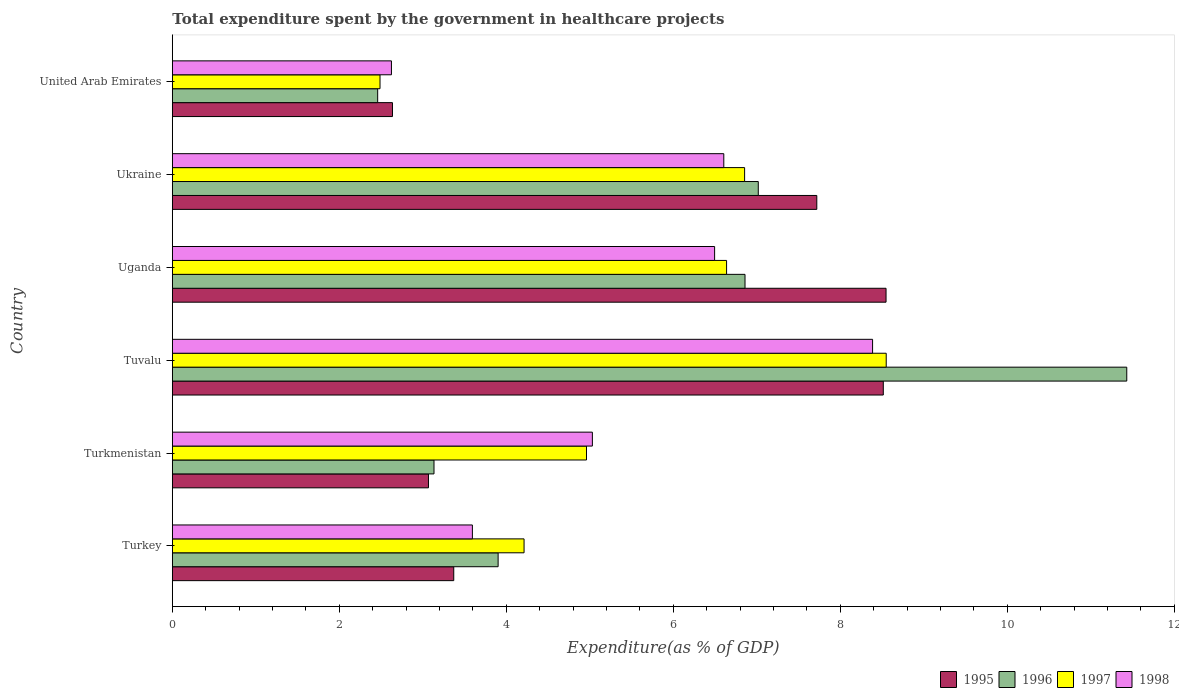Are the number of bars per tick equal to the number of legend labels?
Make the answer very short. Yes. What is the label of the 1st group of bars from the top?
Make the answer very short. United Arab Emirates. What is the total expenditure spent by the government in healthcare projects in 1997 in Uganda?
Provide a short and direct response. 6.64. Across all countries, what is the maximum total expenditure spent by the government in healthcare projects in 1996?
Provide a succinct answer. 11.43. Across all countries, what is the minimum total expenditure spent by the government in healthcare projects in 1995?
Offer a very short reply. 2.64. In which country was the total expenditure spent by the government in healthcare projects in 1996 maximum?
Your response must be concise. Tuvalu. In which country was the total expenditure spent by the government in healthcare projects in 1998 minimum?
Your response must be concise. United Arab Emirates. What is the total total expenditure spent by the government in healthcare projects in 1997 in the graph?
Keep it short and to the point. 33.7. What is the difference between the total expenditure spent by the government in healthcare projects in 1996 in Turkey and that in Uganda?
Provide a succinct answer. -2.96. What is the difference between the total expenditure spent by the government in healthcare projects in 1996 in Turkey and the total expenditure spent by the government in healthcare projects in 1998 in Uganda?
Offer a terse response. -2.59. What is the average total expenditure spent by the government in healthcare projects in 1997 per country?
Give a very brief answer. 5.62. What is the difference between the total expenditure spent by the government in healthcare projects in 1997 and total expenditure spent by the government in healthcare projects in 1998 in Tuvalu?
Offer a very short reply. 0.16. In how many countries, is the total expenditure spent by the government in healthcare projects in 1995 greater than 2.4 %?
Offer a very short reply. 6. What is the ratio of the total expenditure spent by the government in healthcare projects in 1997 in Tuvalu to that in Ukraine?
Your answer should be very brief. 1.25. Is the total expenditure spent by the government in healthcare projects in 1997 in Turkey less than that in Turkmenistan?
Give a very brief answer. Yes. Is the difference between the total expenditure spent by the government in healthcare projects in 1997 in Turkey and Uganda greater than the difference between the total expenditure spent by the government in healthcare projects in 1998 in Turkey and Uganda?
Keep it short and to the point. Yes. What is the difference between the highest and the second highest total expenditure spent by the government in healthcare projects in 1995?
Provide a succinct answer. 0.03. What is the difference between the highest and the lowest total expenditure spent by the government in healthcare projects in 1998?
Give a very brief answer. 5.76. In how many countries, is the total expenditure spent by the government in healthcare projects in 1995 greater than the average total expenditure spent by the government in healthcare projects in 1995 taken over all countries?
Provide a succinct answer. 3. Is the sum of the total expenditure spent by the government in healthcare projects in 1998 in Turkmenistan and Ukraine greater than the maximum total expenditure spent by the government in healthcare projects in 1996 across all countries?
Keep it short and to the point. Yes. Is it the case that in every country, the sum of the total expenditure spent by the government in healthcare projects in 1998 and total expenditure spent by the government in healthcare projects in 1995 is greater than the sum of total expenditure spent by the government in healthcare projects in 1997 and total expenditure spent by the government in healthcare projects in 1996?
Your answer should be very brief. No. Is it the case that in every country, the sum of the total expenditure spent by the government in healthcare projects in 1995 and total expenditure spent by the government in healthcare projects in 1997 is greater than the total expenditure spent by the government in healthcare projects in 1996?
Your answer should be very brief. Yes. Are all the bars in the graph horizontal?
Provide a short and direct response. Yes. How many countries are there in the graph?
Your answer should be very brief. 6. Are the values on the major ticks of X-axis written in scientific E-notation?
Your response must be concise. No. Does the graph contain grids?
Your response must be concise. No. Where does the legend appear in the graph?
Your response must be concise. Bottom right. How many legend labels are there?
Offer a terse response. 4. How are the legend labels stacked?
Keep it short and to the point. Horizontal. What is the title of the graph?
Ensure brevity in your answer.  Total expenditure spent by the government in healthcare projects. Does "2008" appear as one of the legend labels in the graph?
Your answer should be very brief. No. What is the label or title of the X-axis?
Your answer should be very brief. Expenditure(as % of GDP). What is the label or title of the Y-axis?
Provide a succinct answer. Country. What is the Expenditure(as % of GDP) in 1995 in Turkey?
Offer a terse response. 3.37. What is the Expenditure(as % of GDP) of 1996 in Turkey?
Your answer should be very brief. 3.9. What is the Expenditure(as % of GDP) in 1997 in Turkey?
Your response must be concise. 4.21. What is the Expenditure(as % of GDP) in 1998 in Turkey?
Your answer should be very brief. 3.59. What is the Expenditure(as % of GDP) of 1995 in Turkmenistan?
Give a very brief answer. 3.07. What is the Expenditure(as % of GDP) of 1996 in Turkmenistan?
Your answer should be compact. 3.13. What is the Expenditure(as % of GDP) in 1997 in Turkmenistan?
Offer a terse response. 4.96. What is the Expenditure(as % of GDP) of 1998 in Turkmenistan?
Your response must be concise. 5.03. What is the Expenditure(as % of GDP) of 1995 in Tuvalu?
Provide a succinct answer. 8.51. What is the Expenditure(as % of GDP) in 1996 in Tuvalu?
Your response must be concise. 11.43. What is the Expenditure(as % of GDP) in 1997 in Tuvalu?
Offer a very short reply. 8.55. What is the Expenditure(as % of GDP) of 1998 in Tuvalu?
Provide a short and direct response. 8.39. What is the Expenditure(as % of GDP) in 1995 in Uganda?
Ensure brevity in your answer.  8.55. What is the Expenditure(as % of GDP) in 1996 in Uganda?
Make the answer very short. 6.86. What is the Expenditure(as % of GDP) of 1997 in Uganda?
Keep it short and to the point. 6.64. What is the Expenditure(as % of GDP) in 1998 in Uganda?
Your response must be concise. 6.49. What is the Expenditure(as % of GDP) in 1995 in Ukraine?
Offer a terse response. 7.72. What is the Expenditure(as % of GDP) of 1996 in Ukraine?
Your answer should be very brief. 7.02. What is the Expenditure(as % of GDP) of 1997 in Ukraine?
Provide a short and direct response. 6.85. What is the Expenditure(as % of GDP) in 1998 in Ukraine?
Make the answer very short. 6.6. What is the Expenditure(as % of GDP) in 1995 in United Arab Emirates?
Ensure brevity in your answer.  2.64. What is the Expenditure(as % of GDP) in 1996 in United Arab Emirates?
Make the answer very short. 2.46. What is the Expenditure(as % of GDP) of 1997 in United Arab Emirates?
Make the answer very short. 2.49. What is the Expenditure(as % of GDP) in 1998 in United Arab Emirates?
Offer a terse response. 2.62. Across all countries, what is the maximum Expenditure(as % of GDP) of 1995?
Provide a succinct answer. 8.55. Across all countries, what is the maximum Expenditure(as % of GDP) of 1996?
Offer a terse response. 11.43. Across all countries, what is the maximum Expenditure(as % of GDP) in 1997?
Make the answer very short. 8.55. Across all countries, what is the maximum Expenditure(as % of GDP) in 1998?
Provide a succinct answer. 8.39. Across all countries, what is the minimum Expenditure(as % of GDP) in 1995?
Provide a short and direct response. 2.64. Across all countries, what is the minimum Expenditure(as % of GDP) of 1996?
Your answer should be very brief. 2.46. Across all countries, what is the minimum Expenditure(as % of GDP) in 1997?
Give a very brief answer. 2.49. Across all countries, what is the minimum Expenditure(as % of GDP) in 1998?
Ensure brevity in your answer.  2.62. What is the total Expenditure(as % of GDP) of 1995 in the graph?
Provide a succinct answer. 33.85. What is the total Expenditure(as % of GDP) in 1996 in the graph?
Your response must be concise. 34.8. What is the total Expenditure(as % of GDP) in 1997 in the graph?
Make the answer very short. 33.7. What is the total Expenditure(as % of GDP) in 1998 in the graph?
Ensure brevity in your answer.  32.73. What is the difference between the Expenditure(as % of GDP) of 1995 in Turkey and that in Turkmenistan?
Your answer should be compact. 0.3. What is the difference between the Expenditure(as % of GDP) in 1996 in Turkey and that in Turkmenistan?
Offer a terse response. 0.77. What is the difference between the Expenditure(as % of GDP) in 1997 in Turkey and that in Turkmenistan?
Your answer should be very brief. -0.75. What is the difference between the Expenditure(as % of GDP) in 1998 in Turkey and that in Turkmenistan?
Give a very brief answer. -1.44. What is the difference between the Expenditure(as % of GDP) of 1995 in Turkey and that in Tuvalu?
Offer a terse response. -5.14. What is the difference between the Expenditure(as % of GDP) of 1996 in Turkey and that in Tuvalu?
Keep it short and to the point. -7.53. What is the difference between the Expenditure(as % of GDP) of 1997 in Turkey and that in Tuvalu?
Your response must be concise. -4.34. What is the difference between the Expenditure(as % of GDP) of 1998 in Turkey and that in Tuvalu?
Your answer should be compact. -4.79. What is the difference between the Expenditure(as % of GDP) of 1995 in Turkey and that in Uganda?
Provide a short and direct response. -5.18. What is the difference between the Expenditure(as % of GDP) of 1996 in Turkey and that in Uganda?
Offer a very short reply. -2.96. What is the difference between the Expenditure(as % of GDP) in 1997 in Turkey and that in Uganda?
Your response must be concise. -2.43. What is the difference between the Expenditure(as % of GDP) in 1998 in Turkey and that in Uganda?
Your response must be concise. -2.9. What is the difference between the Expenditure(as % of GDP) in 1995 in Turkey and that in Ukraine?
Your response must be concise. -4.35. What is the difference between the Expenditure(as % of GDP) of 1996 in Turkey and that in Ukraine?
Give a very brief answer. -3.12. What is the difference between the Expenditure(as % of GDP) of 1997 in Turkey and that in Ukraine?
Provide a succinct answer. -2.64. What is the difference between the Expenditure(as % of GDP) in 1998 in Turkey and that in Ukraine?
Offer a terse response. -3.01. What is the difference between the Expenditure(as % of GDP) in 1995 in Turkey and that in United Arab Emirates?
Ensure brevity in your answer.  0.73. What is the difference between the Expenditure(as % of GDP) in 1996 in Turkey and that in United Arab Emirates?
Provide a succinct answer. 1.44. What is the difference between the Expenditure(as % of GDP) in 1997 in Turkey and that in United Arab Emirates?
Offer a terse response. 1.73. What is the difference between the Expenditure(as % of GDP) in 1998 in Turkey and that in United Arab Emirates?
Your answer should be very brief. 0.97. What is the difference between the Expenditure(as % of GDP) of 1995 in Turkmenistan and that in Tuvalu?
Your response must be concise. -5.45. What is the difference between the Expenditure(as % of GDP) of 1996 in Turkmenistan and that in Tuvalu?
Provide a short and direct response. -8.3. What is the difference between the Expenditure(as % of GDP) in 1997 in Turkmenistan and that in Tuvalu?
Give a very brief answer. -3.59. What is the difference between the Expenditure(as % of GDP) of 1998 in Turkmenistan and that in Tuvalu?
Keep it short and to the point. -3.36. What is the difference between the Expenditure(as % of GDP) in 1995 in Turkmenistan and that in Uganda?
Your answer should be very brief. -5.48. What is the difference between the Expenditure(as % of GDP) of 1996 in Turkmenistan and that in Uganda?
Offer a terse response. -3.73. What is the difference between the Expenditure(as % of GDP) of 1997 in Turkmenistan and that in Uganda?
Keep it short and to the point. -1.68. What is the difference between the Expenditure(as % of GDP) of 1998 in Turkmenistan and that in Uganda?
Provide a short and direct response. -1.46. What is the difference between the Expenditure(as % of GDP) of 1995 in Turkmenistan and that in Ukraine?
Ensure brevity in your answer.  -4.65. What is the difference between the Expenditure(as % of GDP) in 1996 in Turkmenistan and that in Ukraine?
Ensure brevity in your answer.  -3.88. What is the difference between the Expenditure(as % of GDP) in 1997 in Turkmenistan and that in Ukraine?
Make the answer very short. -1.89. What is the difference between the Expenditure(as % of GDP) of 1998 in Turkmenistan and that in Ukraine?
Ensure brevity in your answer.  -1.57. What is the difference between the Expenditure(as % of GDP) in 1995 in Turkmenistan and that in United Arab Emirates?
Provide a succinct answer. 0.43. What is the difference between the Expenditure(as % of GDP) of 1996 in Turkmenistan and that in United Arab Emirates?
Make the answer very short. 0.67. What is the difference between the Expenditure(as % of GDP) of 1997 in Turkmenistan and that in United Arab Emirates?
Your response must be concise. 2.47. What is the difference between the Expenditure(as % of GDP) of 1998 in Turkmenistan and that in United Arab Emirates?
Make the answer very short. 2.41. What is the difference between the Expenditure(as % of GDP) of 1995 in Tuvalu and that in Uganda?
Provide a short and direct response. -0.03. What is the difference between the Expenditure(as % of GDP) in 1996 in Tuvalu and that in Uganda?
Your answer should be very brief. 4.57. What is the difference between the Expenditure(as % of GDP) in 1997 in Tuvalu and that in Uganda?
Make the answer very short. 1.91. What is the difference between the Expenditure(as % of GDP) in 1998 in Tuvalu and that in Uganda?
Your response must be concise. 1.89. What is the difference between the Expenditure(as % of GDP) of 1995 in Tuvalu and that in Ukraine?
Provide a short and direct response. 0.8. What is the difference between the Expenditure(as % of GDP) in 1996 in Tuvalu and that in Ukraine?
Provide a succinct answer. 4.41. What is the difference between the Expenditure(as % of GDP) of 1997 in Tuvalu and that in Ukraine?
Your answer should be very brief. 1.7. What is the difference between the Expenditure(as % of GDP) of 1998 in Tuvalu and that in Ukraine?
Your answer should be very brief. 1.78. What is the difference between the Expenditure(as % of GDP) in 1995 in Tuvalu and that in United Arab Emirates?
Your answer should be compact. 5.88. What is the difference between the Expenditure(as % of GDP) of 1996 in Tuvalu and that in United Arab Emirates?
Offer a terse response. 8.97. What is the difference between the Expenditure(as % of GDP) in 1997 in Tuvalu and that in United Arab Emirates?
Give a very brief answer. 6.06. What is the difference between the Expenditure(as % of GDP) in 1998 in Tuvalu and that in United Arab Emirates?
Provide a succinct answer. 5.76. What is the difference between the Expenditure(as % of GDP) of 1995 in Uganda and that in Ukraine?
Offer a very short reply. 0.83. What is the difference between the Expenditure(as % of GDP) of 1996 in Uganda and that in Ukraine?
Give a very brief answer. -0.16. What is the difference between the Expenditure(as % of GDP) in 1997 in Uganda and that in Ukraine?
Ensure brevity in your answer.  -0.22. What is the difference between the Expenditure(as % of GDP) of 1998 in Uganda and that in Ukraine?
Provide a short and direct response. -0.11. What is the difference between the Expenditure(as % of GDP) in 1995 in Uganda and that in United Arab Emirates?
Offer a very short reply. 5.91. What is the difference between the Expenditure(as % of GDP) of 1996 in Uganda and that in United Arab Emirates?
Offer a terse response. 4.4. What is the difference between the Expenditure(as % of GDP) of 1997 in Uganda and that in United Arab Emirates?
Give a very brief answer. 4.15. What is the difference between the Expenditure(as % of GDP) of 1998 in Uganda and that in United Arab Emirates?
Keep it short and to the point. 3.87. What is the difference between the Expenditure(as % of GDP) in 1995 in Ukraine and that in United Arab Emirates?
Offer a terse response. 5.08. What is the difference between the Expenditure(as % of GDP) of 1996 in Ukraine and that in United Arab Emirates?
Your answer should be very brief. 4.56. What is the difference between the Expenditure(as % of GDP) of 1997 in Ukraine and that in United Arab Emirates?
Provide a short and direct response. 4.37. What is the difference between the Expenditure(as % of GDP) in 1998 in Ukraine and that in United Arab Emirates?
Give a very brief answer. 3.98. What is the difference between the Expenditure(as % of GDP) in 1995 in Turkey and the Expenditure(as % of GDP) in 1996 in Turkmenistan?
Your answer should be compact. 0.24. What is the difference between the Expenditure(as % of GDP) in 1995 in Turkey and the Expenditure(as % of GDP) in 1997 in Turkmenistan?
Provide a succinct answer. -1.59. What is the difference between the Expenditure(as % of GDP) in 1995 in Turkey and the Expenditure(as % of GDP) in 1998 in Turkmenistan?
Provide a short and direct response. -1.66. What is the difference between the Expenditure(as % of GDP) of 1996 in Turkey and the Expenditure(as % of GDP) of 1997 in Turkmenistan?
Offer a terse response. -1.06. What is the difference between the Expenditure(as % of GDP) of 1996 in Turkey and the Expenditure(as % of GDP) of 1998 in Turkmenistan?
Keep it short and to the point. -1.13. What is the difference between the Expenditure(as % of GDP) of 1997 in Turkey and the Expenditure(as % of GDP) of 1998 in Turkmenistan?
Make the answer very short. -0.82. What is the difference between the Expenditure(as % of GDP) in 1995 in Turkey and the Expenditure(as % of GDP) in 1996 in Tuvalu?
Your response must be concise. -8.06. What is the difference between the Expenditure(as % of GDP) of 1995 in Turkey and the Expenditure(as % of GDP) of 1997 in Tuvalu?
Offer a terse response. -5.18. What is the difference between the Expenditure(as % of GDP) of 1995 in Turkey and the Expenditure(as % of GDP) of 1998 in Tuvalu?
Offer a very short reply. -5.02. What is the difference between the Expenditure(as % of GDP) in 1996 in Turkey and the Expenditure(as % of GDP) in 1997 in Tuvalu?
Your response must be concise. -4.65. What is the difference between the Expenditure(as % of GDP) of 1996 in Turkey and the Expenditure(as % of GDP) of 1998 in Tuvalu?
Provide a short and direct response. -4.48. What is the difference between the Expenditure(as % of GDP) in 1997 in Turkey and the Expenditure(as % of GDP) in 1998 in Tuvalu?
Make the answer very short. -4.17. What is the difference between the Expenditure(as % of GDP) in 1995 in Turkey and the Expenditure(as % of GDP) in 1996 in Uganda?
Ensure brevity in your answer.  -3.49. What is the difference between the Expenditure(as % of GDP) in 1995 in Turkey and the Expenditure(as % of GDP) in 1997 in Uganda?
Make the answer very short. -3.27. What is the difference between the Expenditure(as % of GDP) in 1995 in Turkey and the Expenditure(as % of GDP) in 1998 in Uganda?
Offer a very short reply. -3.12. What is the difference between the Expenditure(as % of GDP) of 1996 in Turkey and the Expenditure(as % of GDP) of 1997 in Uganda?
Your answer should be compact. -2.74. What is the difference between the Expenditure(as % of GDP) of 1996 in Turkey and the Expenditure(as % of GDP) of 1998 in Uganda?
Your response must be concise. -2.59. What is the difference between the Expenditure(as % of GDP) of 1997 in Turkey and the Expenditure(as % of GDP) of 1998 in Uganda?
Your answer should be compact. -2.28. What is the difference between the Expenditure(as % of GDP) in 1995 in Turkey and the Expenditure(as % of GDP) in 1996 in Ukraine?
Offer a terse response. -3.65. What is the difference between the Expenditure(as % of GDP) in 1995 in Turkey and the Expenditure(as % of GDP) in 1997 in Ukraine?
Ensure brevity in your answer.  -3.48. What is the difference between the Expenditure(as % of GDP) in 1995 in Turkey and the Expenditure(as % of GDP) in 1998 in Ukraine?
Keep it short and to the point. -3.23. What is the difference between the Expenditure(as % of GDP) of 1996 in Turkey and the Expenditure(as % of GDP) of 1997 in Ukraine?
Provide a succinct answer. -2.95. What is the difference between the Expenditure(as % of GDP) of 1996 in Turkey and the Expenditure(as % of GDP) of 1998 in Ukraine?
Offer a terse response. -2.7. What is the difference between the Expenditure(as % of GDP) in 1997 in Turkey and the Expenditure(as % of GDP) in 1998 in Ukraine?
Your response must be concise. -2.39. What is the difference between the Expenditure(as % of GDP) of 1995 in Turkey and the Expenditure(as % of GDP) of 1996 in United Arab Emirates?
Offer a very short reply. 0.91. What is the difference between the Expenditure(as % of GDP) of 1995 in Turkey and the Expenditure(as % of GDP) of 1997 in United Arab Emirates?
Keep it short and to the point. 0.88. What is the difference between the Expenditure(as % of GDP) of 1995 in Turkey and the Expenditure(as % of GDP) of 1998 in United Arab Emirates?
Your answer should be very brief. 0.75. What is the difference between the Expenditure(as % of GDP) of 1996 in Turkey and the Expenditure(as % of GDP) of 1997 in United Arab Emirates?
Your response must be concise. 1.41. What is the difference between the Expenditure(as % of GDP) in 1996 in Turkey and the Expenditure(as % of GDP) in 1998 in United Arab Emirates?
Ensure brevity in your answer.  1.28. What is the difference between the Expenditure(as % of GDP) of 1997 in Turkey and the Expenditure(as % of GDP) of 1998 in United Arab Emirates?
Keep it short and to the point. 1.59. What is the difference between the Expenditure(as % of GDP) of 1995 in Turkmenistan and the Expenditure(as % of GDP) of 1996 in Tuvalu?
Offer a very short reply. -8.36. What is the difference between the Expenditure(as % of GDP) in 1995 in Turkmenistan and the Expenditure(as % of GDP) in 1997 in Tuvalu?
Ensure brevity in your answer.  -5.48. What is the difference between the Expenditure(as % of GDP) in 1995 in Turkmenistan and the Expenditure(as % of GDP) in 1998 in Tuvalu?
Offer a terse response. -5.32. What is the difference between the Expenditure(as % of GDP) of 1996 in Turkmenistan and the Expenditure(as % of GDP) of 1997 in Tuvalu?
Keep it short and to the point. -5.42. What is the difference between the Expenditure(as % of GDP) in 1996 in Turkmenistan and the Expenditure(as % of GDP) in 1998 in Tuvalu?
Offer a very short reply. -5.25. What is the difference between the Expenditure(as % of GDP) of 1997 in Turkmenistan and the Expenditure(as % of GDP) of 1998 in Tuvalu?
Give a very brief answer. -3.43. What is the difference between the Expenditure(as % of GDP) of 1995 in Turkmenistan and the Expenditure(as % of GDP) of 1996 in Uganda?
Your answer should be very brief. -3.79. What is the difference between the Expenditure(as % of GDP) in 1995 in Turkmenistan and the Expenditure(as % of GDP) in 1997 in Uganda?
Provide a succinct answer. -3.57. What is the difference between the Expenditure(as % of GDP) of 1995 in Turkmenistan and the Expenditure(as % of GDP) of 1998 in Uganda?
Your response must be concise. -3.43. What is the difference between the Expenditure(as % of GDP) in 1996 in Turkmenistan and the Expenditure(as % of GDP) in 1997 in Uganda?
Provide a short and direct response. -3.5. What is the difference between the Expenditure(as % of GDP) of 1996 in Turkmenistan and the Expenditure(as % of GDP) of 1998 in Uganda?
Make the answer very short. -3.36. What is the difference between the Expenditure(as % of GDP) of 1997 in Turkmenistan and the Expenditure(as % of GDP) of 1998 in Uganda?
Provide a succinct answer. -1.53. What is the difference between the Expenditure(as % of GDP) of 1995 in Turkmenistan and the Expenditure(as % of GDP) of 1996 in Ukraine?
Keep it short and to the point. -3.95. What is the difference between the Expenditure(as % of GDP) in 1995 in Turkmenistan and the Expenditure(as % of GDP) in 1997 in Ukraine?
Your answer should be compact. -3.79. What is the difference between the Expenditure(as % of GDP) in 1995 in Turkmenistan and the Expenditure(as % of GDP) in 1998 in Ukraine?
Offer a terse response. -3.54. What is the difference between the Expenditure(as % of GDP) in 1996 in Turkmenistan and the Expenditure(as % of GDP) in 1997 in Ukraine?
Your answer should be compact. -3.72. What is the difference between the Expenditure(as % of GDP) of 1996 in Turkmenistan and the Expenditure(as % of GDP) of 1998 in Ukraine?
Offer a very short reply. -3.47. What is the difference between the Expenditure(as % of GDP) of 1997 in Turkmenistan and the Expenditure(as % of GDP) of 1998 in Ukraine?
Keep it short and to the point. -1.64. What is the difference between the Expenditure(as % of GDP) in 1995 in Turkmenistan and the Expenditure(as % of GDP) in 1996 in United Arab Emirates?
Make the answer very short. 0.61. What is the difference between the Expenditure(as % of GDP) of 1995 in Turkmenistan and the Expenditure(as % of GDP) of 1997 in United Arab Emirates?
Give a very brief answer. 0.58. What is the difference between the Expenditure(as % of GDP) in 1995 in Turkmenistan and the Expenditure(as % of GDP) in 1998 in United Arab Emirates?
Offer a terse response. 0.44. What is the difference between the Expenditure(as % of GDP) in 1996 in Turkmenistan and the Expenditure(as % of GDP) in 1997 in United Arab Emirates?
Keep it short and to the point. 0.65. What is the difference between the Expenditure(as % of GDP) of 1996 in Turkmenistan and the Expenditure(as % of GDP) of 1998 in United Arab Emirates?
Provide a short and direct response. 0.51. What is the difference between the Expenditure(as % of GDP) in 1997 in Turkmenistan and the Expenditure(as % of GDP) in 1998 in United Arab Emirates?
Make the answer very short. 2.34. What is the difference between the Expenditure(as % of GDP) of 1995 in Tuvalu and the Expenditure(as % of GDP) of 1996 in Uganda?
Keep it short and to the point. 1.66. What is the difference between the Expenditure(as % of GDP) of 1995 in Tuvalu and the Expenditure(as % of GDP) of 1997 in Uganda?
Offer a terse response. 1.88. What is the difference between the Expenditure(as % of GDP) of 1995 in Tuvalu and the Expenditure(as % of GDP) of 1998 in Uganda?
Provide a short and direct response. 2.02. What is the difference between the Expenditure(as % of GDP) in 1996 in Tuvalu and the Expenditure(as % of GDP) in 1997 in Uganda?
Your answer should be compact. 4.79. What is the difference between the Expenditure(as % of GDP) in 1996 in Tuvalu and the Expenditure(as % of GDP) in 1998 in Uganda?
Give a very brief answer. 4.94. What is the difference between the Expenditure(as % of GDP) in 1997 in Tuvalu and the Expenditure(as % of GDP) in 1998 in Uganda?
Offer a terse response. 2.06. What is the difference between the Expenditure(as % of GDP) in 1995 in Tuvalu and the Expenditure(as % of GDP) in 1996 in Ukraine?
Ensure brevity in your answer.  1.5. What is the difference between the Expenditure(as % of GDP) of 1995 in Tuvalu and the Expenditure(as % of GDP) of 1997 in Ukraine?
Give a very brief answer. 1.66. What is the difference between the Expenditure(as % of GDP) of 1995 in Tuvalu and the Expenditure(as % of GDP) of 1998 in Ukraine?
Provide a short and direct response. 1.91. What is the difference between the Expenditure(as % of GDP) in 1996 in Tuvalu and the Expenditure(as % of GDP) in 1997 in Ukraine?
Provide a short and direct response. 4.58. What is the difference between the Expenditure(as % of GDP) of 1996 in Tuvalu and the Expenditure(as % of GDP) of 1998 in Ukraine?
Give a very brief answer. 4.83. What is the difference between the Expenditure(as % of GDP) of 1997 in Tuvalu and the Expenditure(as % of GDP) of 1998 in Ukraine?
Keep it short and to the point. 1.95. What is the difference between the Expenditure(as % of GDP) of 1995 in Tuvalu and the Expenditure(as % of GDP) of 1996 in United Arab Emirates?
Your response must be concise. 6.06. What is the difference between the Expenditure(as % of GDP) of 1995 in Tuvalu and the Expenditure(as % of GDP) of 1997 in United Arab Emirates?
Make the answer very short. 6.03. What is the difference between the Expenditure(as % of GDP) of 1995 in Tuvalu and the Expenditure(as % of GDP) of 1998 in United Arab Emirates?
Ensure brevity in your answer.  5.89. What is the difference between the Expenditure(as % of GDP) in 1996 in Tuvalu and the Expenditure(as % of GDP) in 1997 in United Arab Emirates?
Make the answer very short. 8.94. What is the difference between the Expenditure(as % of GDP) of 1996 in Tuvalu and the Expenditure(as % of GDP) of 1998 in United Arab Emirates?
Offer a very short reply. 8.81. What is the difference between the Expenditure(as % of GDP) in 1997 in Tuvalu and the Expenditure(as % of GDP) in 1998 in United Arab Emirates?
Give a very brief answer. 5.93. What is the difference between the Expenditure(as % of GDP) of 1995 in Uganda and the Expenditure(as % of GDP) of 1996 in Ukraine?
Provide a short and direct response. 1.53. What is the difference between the Expenditure(as % of GDP) of 1995 in Uganda and the Expenditure(as % of GDP) of 1997 in Ukraine?
Provide a succinct answer. 1.69. What is the difference between the Expenditure(as % of GDP) of 1995 in Uganda and the Expenditure(as % of GDP) of 1998 in Ukraine?
Give a very brief answer. 1.94. What is the difference between the Expenditure(as % of GDP) of 1996 in Uganda and the Expenditure(as % of GDP) of 1997 in Ukraine?
Make the answer very short. 0. What is the difference between the Expenditure(as % of GDP) in 1996 in Uganda and the Expenditure(as % of GDP) in 1998 in Ukraine?
Provide a short and direct response. 0.25. What is the difference between the Expenditure(as % of GDP) in 1997 in Uganda and the Expenditure(as % of GDP) in 1998 in Ukraine?
Offer a terse response. 0.03. What is the difference between the Expenditure(as % of GDP) in 1995 in Uganda and the Expenditure(as % of GDP) in 1996 in United Arab Emirates?
Your answer should be compact. 6.09. What is the difference between the Expenditure(as % of GDP) of 1995 in Uganda and the Expenditure(as % of GDP) of 1997 in United Arab Emirates?
Give a very brief answer. 6.06. What is the difference between the Expenditure(as % of GDP) of 1995 in Uganda and the Expenditure(as % of GDP) of 1998 in United Arab Emirates?
Keep it short and to the point. 5.92. What is the difference between the Expenditure(as % of GDP) in 1996 in Uganda and the Expenditure(as % of GDP) in 1997 in United Arab Emirates?
Your answer should be very brief. 4.37. What is the difference between the Expenditure(as % of GDP) in 1996 in Uganda and the Expenditure(as % of GDP) in 1998 in United Arab Emirates?
Make the answer very short. 4.23. What is the difference between the Expenditure(as % of GDP) in 1997 in Uganda and the Expenditure(as % of GDP) in 1998 in United Arab Emirates?
Keep it short and to the point. 4.01. What is the difference between the Expenditure(as % of GDP) in 1995 in Ukraine and the Expenditure(as % of GDP) in 1996 in United Arab Emirates?
Offer a very short reply. 5.26. What is the difference between the Expenditure(as % of GDP) of 1995 in Ukraine and the Expenditure(as % of GDP) of 1997 in United Arab Emirates?
Offer a very short reply. 5.23. What is the difference between the Expenditure(as % of GDP) in 1995 in Ukraine and the Expenditure(as % of GDP) in 1998 in United Arab Emirates?
Your answer should be compact. 5.09. What is the difference between the Expenditure(as % of GDP) of 1996 in Ukraine and the Expenditure(as % of GDP) of 1997 in United Arab Emirates?
Offer a terse response. 4.53. What is the difference between the Expenditure(as % of GDP) in 1996 in Ukraine and the Expenditure(as % of GDP) in 1998 in United Arab Emirates?
Give a very brief answer. 4.39. What is the difference between the Expenditure(as % of GDP) in 1997 in Ukraine and the Expenditure(as % of GDP) in 1998 in United Arab Emirates?
Provide a short and direct response. 4.23. What is the average Expenditure(as % of GDP) of 1995 per country?
Your answer should be compact. 5.64. What is the average Expenditure(as % of GDP) of 1997 per country?
Ensure brevity in your answer.  5.62. What is the average Expenditure(as % of GDP) in 1998 per country?
Make the answer very short. 5.46. What is the difference between the Expenditure(as % of GDP) in 1995 and Expenditure(as % of GDP) in 1996 in Turkey?
Ensure brevity in your answer.  -0.53. What is the difference between the Expenditure(as % of GDP) in 1995 and Expenditure(as % of GDP) in 1997 in Turkey?
Provide a short and direct response. -0.84. What is the difference between the Expenditure(as % of GDP) of 1995 and Expenditure(as % of GDP) of 1998 in Turkey?
Give a very brief answer. -0.22. What is the difference between the Expenditure(as % of GDP) of 1996 and Expenditure(as % of GDP) of 1997 in Turkey?
Provide a short and direct response. -0.31. What is the difference between the Expenditure(as % of GDP) of 1996 and Expenditure(as % of GDP) of 1998 in Turkey?
Your answer should be compact. 0.31. What is the difference between the Expenditure(as % of GDP) in 1997 and Expenditure(as % of GDP) in 1998 in Turkey?
Offer a terse response. 0.62. What is the difference between the Expenditure(as % of GDP) of 1995 and Expenditure(as % of GDP) of 1996 in Turkmenistan?
Your answer should be very brief. -0.07. What is the difference between the Expenditure(as % of GDP) of 1995 and Expenditure(as % of GDP) of 1997 in Turkmenistan?
Keep it short and to the point. -1.89. What is the difference between the Expenditure(as % of GDP) of 1995 and Expenditure(as % of GDP) of 1998 in Turkmenistan?
Offer a terse response. -1.96. What is the difference between the Expenditure(as % of GDP) in 1996 and Expenditure(as % of GDP) in 1997 in Turkmenistan?
Offer a terse response. -1.83. What is the difference between the Expenditure(as % of GDP) of 1996 and Expenditure(as % of GDP) of 1998 in Turkmenistan?
Give a very brief answer. -1.9. What is the difference between the Expenditure(as % of GDP) in 1997 and Expenditure(as % of GDP) in 1998 in Turkmenistan?
Provide a short and direct response. -0.07. What is the difference between the Expenditure(as % of GDP) of 1995 and Expenditure(as % of GDP) of 1996 in Tuvalu?
Keep it short and to the point. -2.92. What is the difference between the Expenditure(as % of GDP) of 1995 and Expenditure(as % of GDP) of 1997 in Tuvalu?
Offer a terse response. -0.04. What is the difference between the Expenditure(as % of GDP) in 1995 and Expenditure(as % of GDP) in 1998 in Tuvalu?
Provide a succinct answer. 0.13. What is the difference between the Expenditure(as % of GDP) in 1996 and Expenditure(as % of GDP) in 1997 in Tuvalu?
Your answer should be compact. 2.88. What is the difference between the Expenditure(as % of GDP) of 1996 and Expenditure(as % of GDP) of 1998 in Tuvalu?
Offer a terse response. 3.04. What is the difference between the Expenditure(as % of GDP) of 1997 and Expenditure(as % of GDP) of 1998 in Tuvalu?
Provide a short and direct response. 0.16. What is the difference between the Expenditure(as % of GDP) of 1995 and Expenditure(as % of GDP) of 1996 in Uganda?
Offer a very short reply. 1.69. What is the difference between the Expenditure(as % of GDP) in 1995 and Expenditure(as % of GDP) in 1997 in Uganda?
Ensure brevity in your answer.  1.91. What is the difference between the Expenditure(as % of GDP) in 1995 and Expenditure(as % of GDP) in 1998 in Uganda?
Keep it short and to the point. 2.05. What is the difference between the Expenditure(as % of GDP) in 1996 and Expenditure(as % of GDP) in 1997 in Uganda?
Offer a terse response. 0.22. What is the difference between the Expenditure(as % of GDP) in 1996 and Expenditure(as % of GDP) in 1998 in Uganda?
Make the answer very short. 0.36. What is the difference between the Expenditure(as % of GDP) of 1997 and Expenditure(as % of GDP) of 1998 in Uganda?
Provide a succinct answer. 0.14. What is the difference between the Expenditure(as % of GDP) in 1995 and Expenditure(as % of GDP) in 1996 in Ukraine?
Provide a short and direct response. 0.7. What is the difference between the Expenditure(as % of GDP) in 1995 and Expenditure(as % of GDP) in 1997 in Ukraine?
Ensure brevity in your answer.  0.86. What is the difference between the Expenditure(as % of GDP) in 1995 and Expenditure(as % of GDP) in 1998 in Ukraine?
Make the answer very short. 1.11. What is the difference between the Expenditure(as % of GDP) of 1996 and Expenditure(as % of GDP) of 1997 in Ukraine?
Offer a terse response. 0.16. What is the difference between the Expenditure(as % of GDP) in 1996 and Expenditure(as % of GDP) in 1998 in Ukraine?
Provide a succinct answer. 0.41. What is the difference between the Expenditure(as % of GDP) of 1997 and Expenditure(as % of GDP) of 1998 in Ukraine?
Offer a terse response. 0.25. What is the difference between the Expenditure(as % of GDP) in 1995 and Expenditure(as % of GDP) in 1996 in United Arab Emirates?
Make the answer very short. 0.18. What is the difference between the Expenditure(as % of GDP) in 1995 and Expenditure(as % of GDP) in 1997 in United Arab Emirates?
Give a very brief answer. 0.15. What is the difference between the Expenditure(as % of GDP) in 1995 and Expenditure(as % of GDP) in 1998 in United Arab Emirates?
Keep it short and to the point. 0.01. What is the difference between the Expenditure(as % of GDP) in 1996 and Expenditure(as % of GDP) in 1997 in United Arab Emirates?
Your response must be concise. -0.03. What is the difference between the Expenditure(as % of GDP) of 1996 and Expenditure(as % of GDP) of 1998 in United Arab Emirates?
Offer a terse response. -0.16. What is the difference between the Expenditure(as % of GDP) in 1997 and Expenditure(as % of GDP) in 1998 in United Arab Emirates?
Ensure brevity in your answer.  -0.14. What is the ratio of the Expenditure(as % of GDP) in 1995 in Turkey to that in Turkmenistan?
Provide a succinct answer. 1.1. What is the ratio of the Expenditure(as % of GDP) in 1996 in Turkey to that in Turkmenistan?
Give a very brief answer. 1.25. What is the ratio of the Expenditure(as % of GDP) in 1997 in Turkey to that in Turkmenistan?
Make the answer very short. 0.85. What is the ratio of the Expenditure(as % of GDP) of 1998 in Turkey to that in Turkmenistan?
Make the answer very short. 0.71. What is the ratio of the Expenditure(as % of GDP) of 1995 in Turkey to that in Tuvalu?
Offer a terse response. 0.4. What is the ratio of the Expenditure(as % of GDP) of 1996 in Turkey to that in Tuvalu?
Keep it short and to the point. 0.34. What is the ratio of the Expenditure(as % of GDP) of 1997 in Turkey to that in Tuvalu?
Offer a very short reply. 0.49. What is the ratio of the Expenditure(as % of GDP) of 1998 in Turkey to that in Tuvalu?
Give a very brief answer. 0.43. What is the ratio of the Expenditure(as % of GDP) of 1995 in Turkey to that in Uganda?
Make the answer very short. 0.39. What is the ratio of the Expenditure(as % of GDP) of 1996 in Turkey to that in Uganda?
Your response must be concise. 0.57. What is the ratio of the Expenditure(as % of GDP) of 1997 in Turkey to that in Uganda?
Offer a very short reply. 0.63. What is the ratio of the Expenditure(as % of GDP) of 1998 in Turkey to that in Uganda?
Ensure brevity in your answer.  0.55. What is the ratio of the Expenditure(as % of GDP) of 1995 in Turkey to that in Ukraine?
Ensure brevity in your answer.  0.44. What is the ratio of the Expenditure(as % of GDP) of 1996 in Turkey to that in Ukraine?
Ensure brevity in your answer.  0.56. What is the ratio of the Expenditure(as % of GDP) of 1997 in Turkey to that in Ukraine?
Make the answer very short. 0.61. What is the ratio of the Expenditure(as % of GDP) of 1998 in Turkey to that in Ukraine?
Your answer should be very brief. 0.54. What is the ratio of the Expenditure(as % of GDP) of 1995 in Turkey to that in United Arab Emirates?
Your response must be concise. 1.28. What is the ratio of the Expenditure(as % of GDP) of 1996 in Turkey to that in United Arab Emirates?
Make the answer very short. 1.59. What is the ratio of the Expenditure(as % of GDP) of 1997 in Turkey to that in United Arab Emirates?
Your answer should be very brief. 1.69. What is the ratio of the Expenditure(as % of GDP) in 1998 in Turkey to that in United Arab Emirates?
Your answer should be very brief. 1.37. What is the ratio of the Expenditure(as % of GDP) of 1995 in Turkmenistan to that in Tuvalu?
Your answer should be compact. 0.36. What is the ratio of the Expenditure(as % of GDP) in 1996 in Turkmenistan to that in Tuvalu?
Your answer should be compact. 0.27. What is the ratio of the Expenditure(as % of GDP) in 1997 in Turkmenistan to that in Tuvalu?
Give a very brief answer. 0.58. What is the ratio of the Expenditure(as % of GDP) in 1998 in Turkmenistan to that in Tuvalu?
Your response must be concise. 0.6. What is the ratio of the Expenditure(as % of GDP) of 1995 in Turkmenistan to that in Uganda?
Your answer should be compact. 0.36. What is the ratio of the Expenditure(as % of GDP) of 1996 in Turkmenistan to that in Uganda?
Your response must be concise. 0.46. What is the ratio of the Expenditure(as % of GDP) of 1997 in Turkmenistan to that in Uganda?
Give a very brief answer. 0.75. What is the ratio of the Expenditure(as % of GDP) in 1998 in Turkmenistan to that in Uganda?
Your answer should be very brief. 0.77. What is the ratio of the Expenditure(as % of GDP) of 1995 in Turkmenistan to that in Ukraine?
Give a very brief answer. 0.4. What is the ratio of the Expenditure(as % of GDP) of 1996 in Turkmenistan to that in Ukraine?
Offer a terse response. 0.45. What is the ratio of the Expenditure(as % of GDP) of 1997 in Turkmenistan to that in Ukraine?
Your response must be concise. 0.72. What is the ratio of the Expenditure(as % of GDP) of 1998 in Turkmenistan to that in Ukraine?
Provide a succinct answer. 0.76. What is the ratio of the Expenditure(as % of GDP) of 1995 in Turkmenistan to that in United Arab Emirates?
Give a very brief answer. 1.16. What is the ratio of the Expenditure(as % of GDP) in 1996 in Turkmenistan to that in United Arab Emirates?
Provide a succinct answer. 1.27. What is the ratio of the Expenditure(as % of GDP) of 1997 in Turkmenistan to that in United Arab Emirates?
Your answer should be very brief. 1.99. What is the ratio of the Expenditure(as % of GDP) in 1998 in Turkmenistan to that in United Arab Emirates?
Your answer should be compact. 1.92. What is the ratio of the Expenditure(as % of GDP) of 1996 in Tuvalu to that in Uganda?
Your answer should be compact. 1.67. What is the ratio of the Expenditure(as % of GDP) of 1997 in Tuvalu to that in Uganda?
Offer a terse response. 1.29. What is the ratio of the Expenditure(as % of GDP) of 1998 in Tuvalu to that in Uganda?
Make the answer very short. 1.29. What is the ratio of the Expenditure(as % of GDP) of 1995 in Tuvalu to that in Ukraine?
Your response must be concise. 1.1. What is the ratio of the Expenditure(as % of GDP) in 1996 in Tuvalu to that in Ukraine?
Ensure brevity in your answer.  1.63. What is the ratio of the Expenditure(as % of GDP) in 1997 in Tuvalu to that in Ukraine?
Your response must be concise. 1.25. What is the ratio of the Expenditure(as % of GDP) of 1998 in Tuvalu to that in Ukraine?
Offer a terse response. 1.27. What is the ratio of the Expenditure(as % of GDP) in 1995 in Tuvalu to that in United Arab Emirates?
Your response must be concise. 3.23. What is the ratio of the Expenditure(as % of GDP) of 1996 in Tuvalu to that in United Arab Emirates?
Ensure brevity in your answer.  4.65. What is the ratio of the Expenditure(as % of GDP) in 1997 in Tuvalu to that in United Arab Emirates?
Your answer should be compact. 3.44. What is the ratio of the Expenditure(as % of GDP) in 1998 in Tuvalu to that in United Arab Emirates?
Ensure brevity in your answer.  3.2. What is the ratio of the Expenditure(as % of GDP) of 1995 in Uganda to that in Ukraine?
Ensure brevity in your answer.  1.11. What is the ratio of the Expenditure(as % of GDP) of 1996 in Uganda to that in Ukraine?
Your answer should be compact. 0.98. What is the ratio of the Expenditure(as % of GDP) of 1997 in Uganda to that in Ukraine?
Make the answer very short. 0.97. What is the ratio of the Expenditure(as % of GDP) of 1998 in Uganda to that in Ukraine?
Your answer should be very brief. 0.98. What is the ratio of the Expenditure(as % of GDP) of 1995 in Uganda to that in United Arab Emirates?
Give a very brief answer. 3.24. What is the ratio of the Expenditure(as % of GDP) in 1996 in Uganda to that in United Arab Emirates?
Provide a short and direct response. 2.79. What is the ratio of the Expenditure(as % of GDP) in 1997 in Uganda to that in United Arab Emirates?
Make the answer very short. 2.67. What is the ratio of the Expenditure(as % of GDP) of 1998 in Uganda to that in United Arab Emirates?
Offer a terse response. 2.48. What is the ratio of the Expenditure(as % of GDP) of 1995 in Ukraine to that in United Arab Emirates?
Provide a succinct answer. 2.93. What is the ratio of the Expenditure(as % of GDP) in 1996 in Ukraine to that in United Arab Emirates?
Keep it short and to the point. 2.85. What is the ratio of the Expenditure(as % of GDP) in 1997 in Ukraine to that in United Arab Emirates?
Offer a very short reply. 2.76. What is the ratio of the Expenditure(as % of GDP) in 1998 in Ukraine to that in United Arab Emirates?
Provide a succinct answer. 2.52. What is the difference between the highest and the second highest Expenditure(as % of GDP) in 1995?
Provide a short and direct response. 0.03. What is the difference between the highest and the second highest Expenditure(as % of GDP) of 1996?
Your answer should be compact. 4.41. What is the difference between the highest and the second highest Expenditure(as % of GDP) in 1997?
Provide a succinct answer. 1.7. What is the difference between the highest and the second highest Expenditure(as % of GDP) in 1998?
Give a very brief answer. 1.78. What is the difference between the highest and the lowest Expenditure(as % of GDP) of 1995?
Your answer should be compact. 5.91. What is the difference between the highest and the lowest Expenditure(as % of GDP) of 1996?
Make the answer very short. 8.97. What is the difference between the highest and the lowest Expenditure(as % of GDP) of 1997?
Ensure brevity in your answer.  6.06. What is the difference between the highest and the lowest Expenditure(as % of GDP) of 1998?
Offer a terse response. 5.76. 